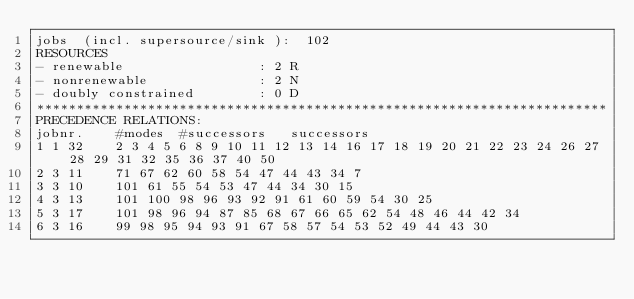Convert code to text. <code><loc_0><loc_0><loc_500><loc_500><_ObjectiveC_>jobs  (incl. supersource/sink ):	102
RESOURCES
- renewable                 : 2 R
- nonrenewable              : 2 N
- doubly constrained        : 0 D
************************************************************************
PRECEDENCE RELATIONS:
jobnr.    #modes  #successors   successors
1	1	32		2 3 4 5 6 8 9 10 11 12 13 14 16 17 18 19 20 21 22 23 24 26 27 28 29 31 32 35 36 37 40 50 
2	3	11		71 67 62 60 58 54 47 44 43 34 7 
3	3	10		101 61 55 54 53 47 44 34 30 15 
4	3	13		101 100 98 96 93 92 91 61 60 59 54 30 25 
5	3	17		101 98 96 94 87 85 68 67 66 65 62 54 48 46 44 42 34 
6	3	16		99 98 95 94 93 91 67 58 57 54 53 52 49 44 43 30 </code> 